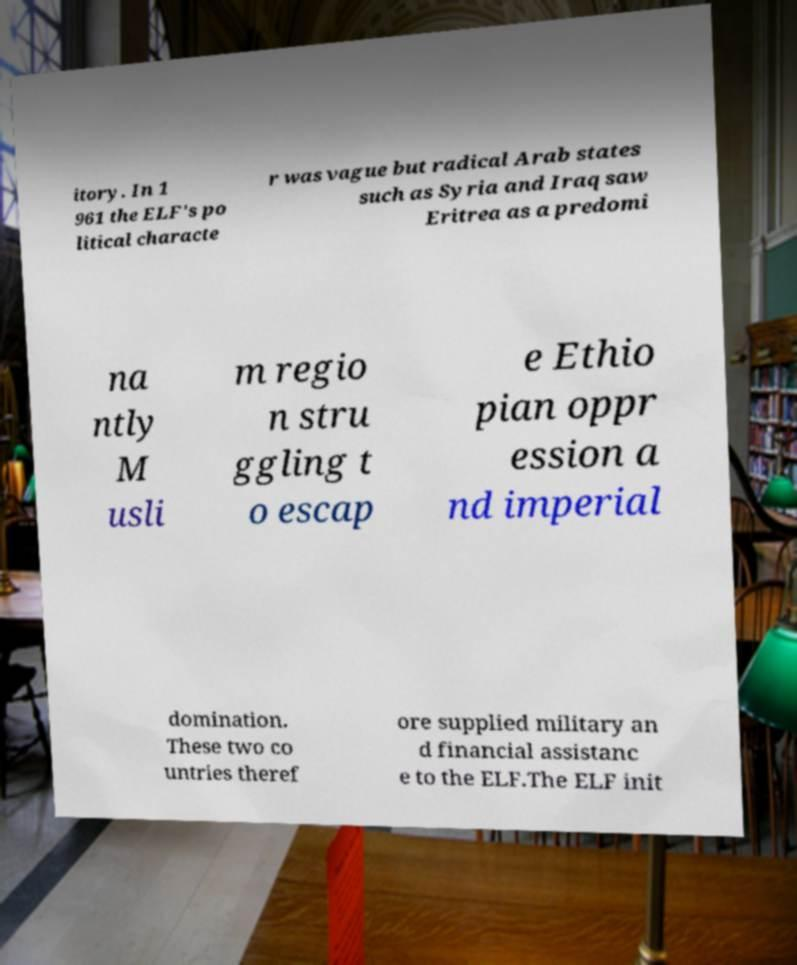There's text embedded in this image that I need extracted. Can you transcribe it verbatim? itory. In 1 961 the ELF's po litical characte r was vague but radical Arab states such as Syria and Iraq saw Eritrea as a predomi na ntly M usli m regio n stru ggling t o escap e Ethio pian oppr ession a nd imperial domination. These two co untries theref ore supplied military an d financial assistanc e to the ELF.The ELF init 